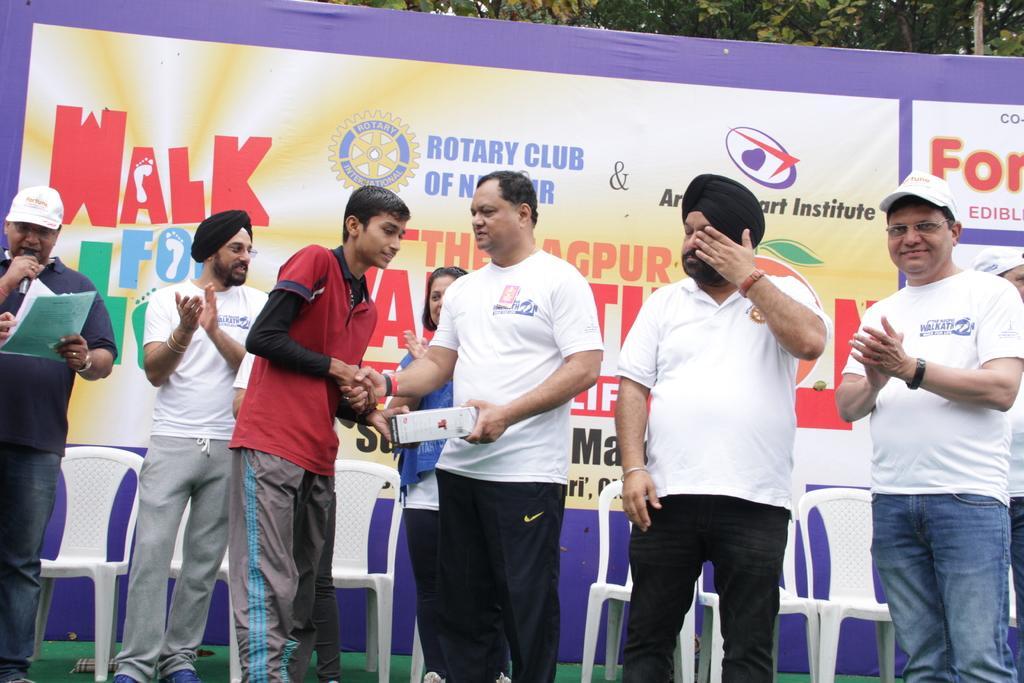How would you summarize this image in a sentence or two? In this image we can see some people standing on the stage, some white color chairs on the stage, green carpet on the stage, one big banner with text and logo backside of these persons. There are some trees, one pole backside of the banner, left side of the image one man holding papers, file, microphone and talking. Middle of the image one man with a white T shirt giving an award to the boy with a red T shirt. 